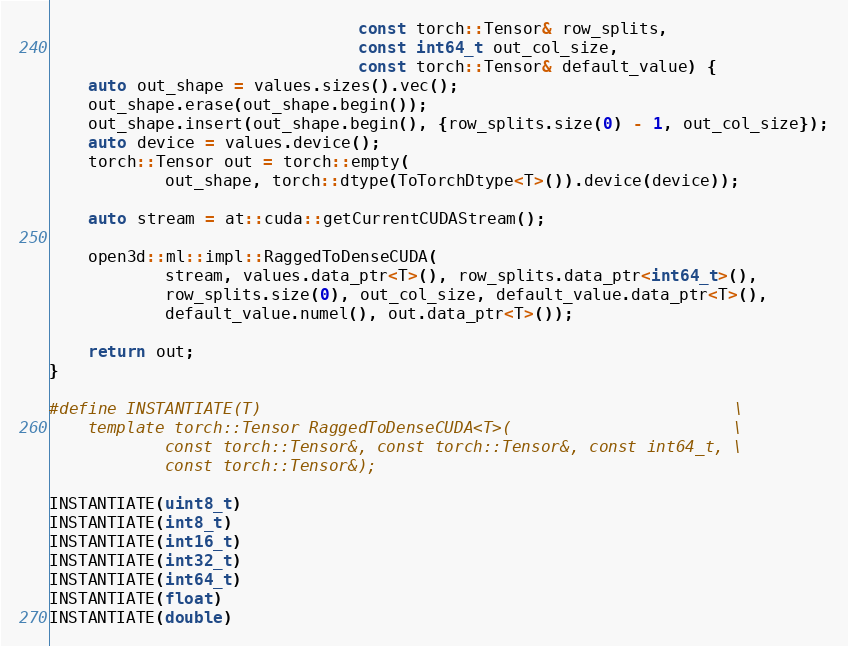Convert code to text. <code><loc_0><loc_0><loc_500><loc_500><_Cuda_>                                const torch::Tensor& row_splits,
                                const int64_t out_col_size,
                                const torch::Tensor& default_value) {
    auto out_shape = values.sizes().vec();
    out_shape.erase(out_shape.begin());
    out_shape.insert(out_shape.begin(), {row_splits.size(0) - 1, out_col_size});
    auto device = values.device();
    torch::Tensor out = torch::empty(
            out_shape, torch::dtype(ToTorchDtype<T>()).device(device));

    auto stream = at::cuda::getCurrentCUDAStream();

    open3d::ml::impl::RaggedToDenseCUDA(
            stream, values.data_ptr<T>(), row_splits.data_ptr<int64_t>(),
            row_splits.size(0), out_col_size, default_value.data_ptr<T>(),
            default_value.numel(), out.data_ptr<T>());

    return out;
}

#define INSTANTIATE(T)                                                 \
    template torch::Tensor RaggedToDenseCUDA<T>(                       \
            const torch::Tensor&, const torch::Tensor&, const int64_t, \
            const torch::Tensor&);

INSTANTIATE(uint8_t)
INSTANTIATE(int8_t)
INSTANTIATE(int16_t)
INSTANTIATE(int32_t)
INSTANTIATE(int64_t)
INSTANTIATE(float)
INSTANTIATE(double)
</code> 